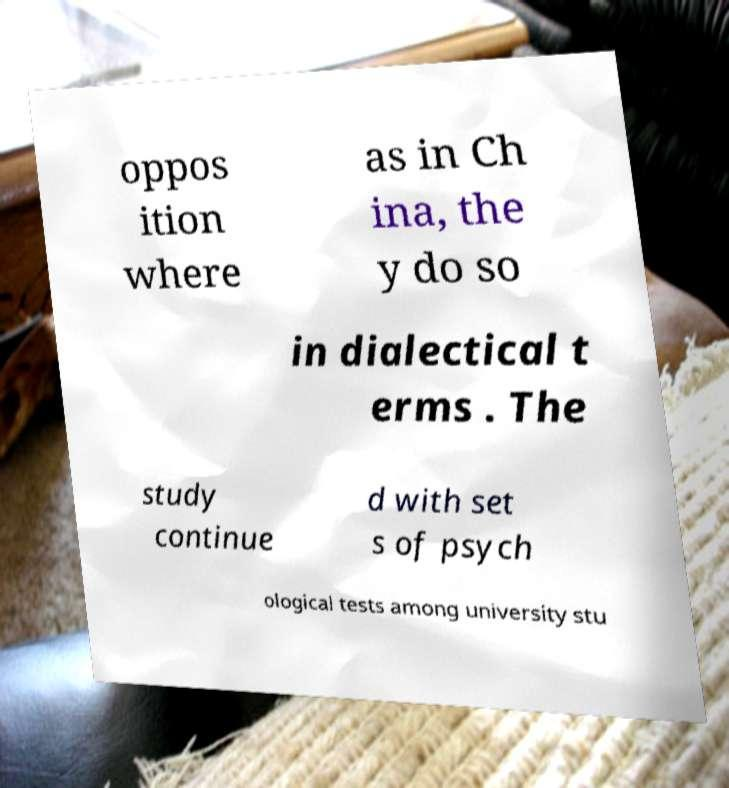Please read and relay the text visible in this image. What does it say? oppos ition where as in Ch ina, the y do so in dialectical t erms . The study continue d with set s of psych ological tests among university stu 